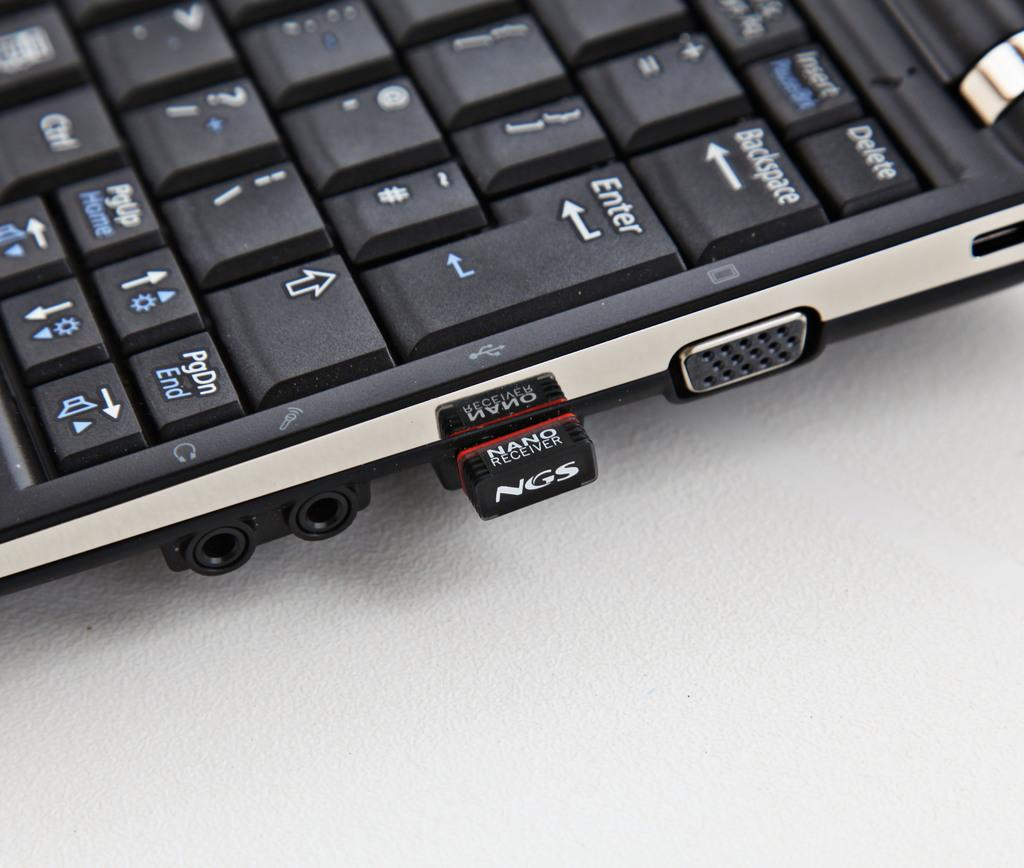<image>
Provide a brief description of the given image. A laptop has an NGS brand micro USB inserted. 